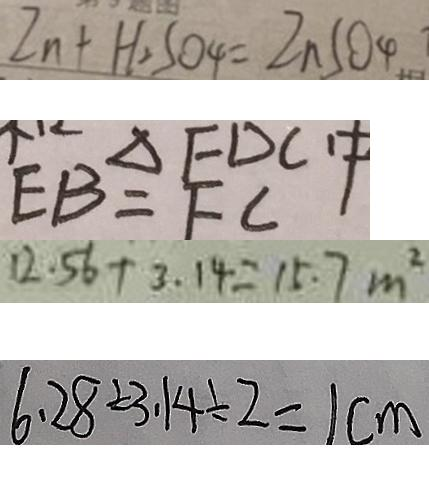Convert formula to latex. <formula><loc_0><loc_0><loc_500><loc_500>Z n + H _ { 2 } S O _ { 4 } = Z n S O _ { 4 } 
 E B = F C 
 1 2 . 5 6 + 3 . 1 4 = 1 5 . 7 m ^ { 2 } 
 6 . 2 8 \div 3 . 1 4 \div 2 = 1 c m</formula> 